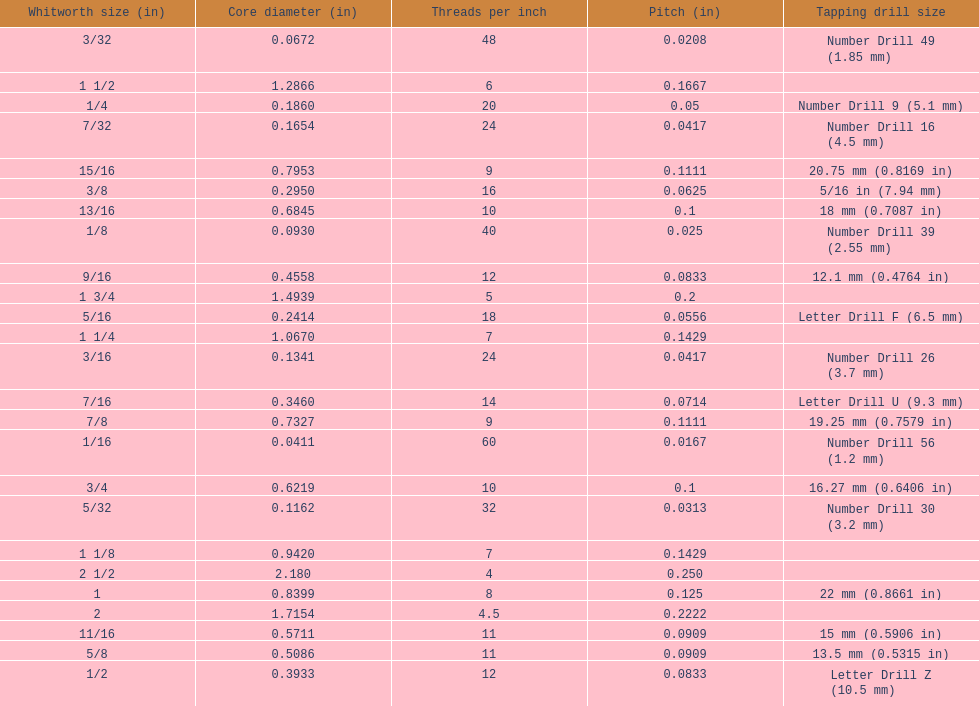What is the next whitworth size (in) below 1/8? 5/32. 